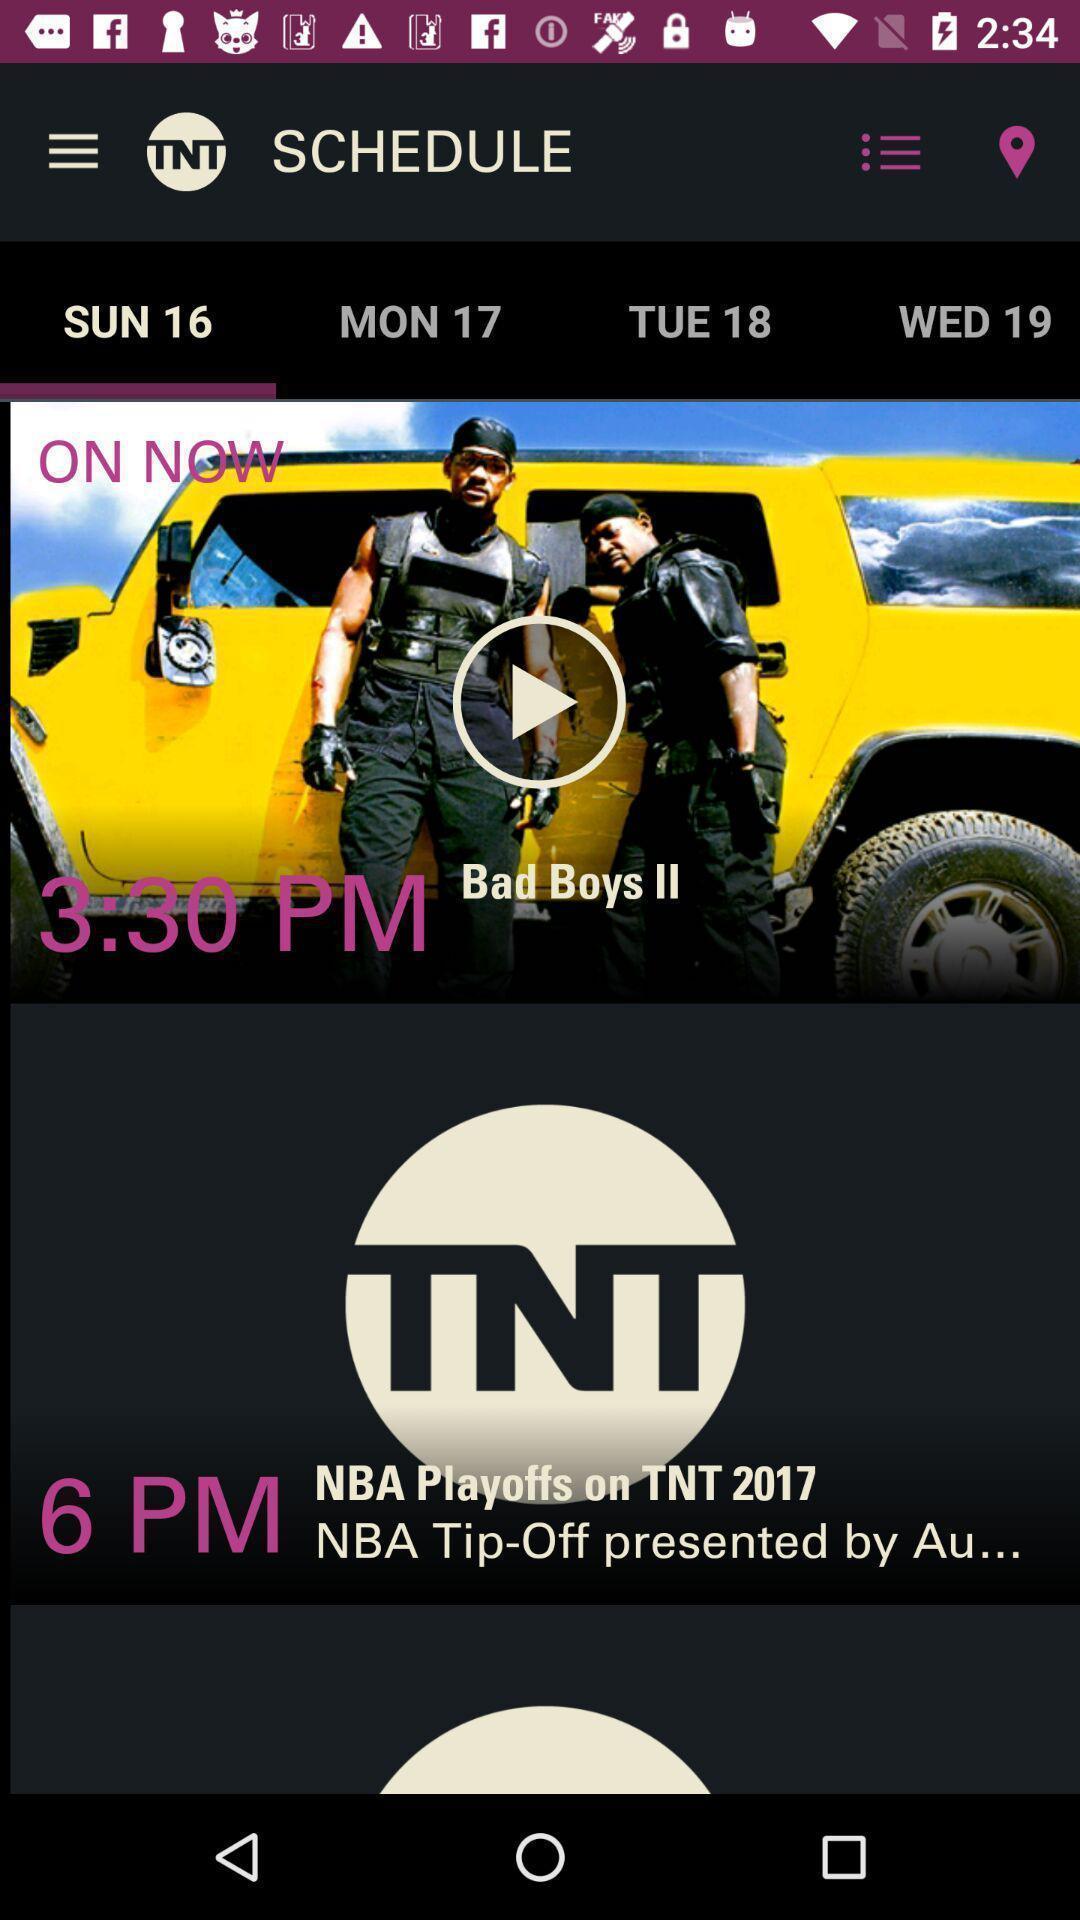Describe the key features of this screenshot. Page showing movies. 